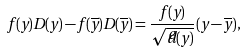<formula> <loc_0><loc_0><loc_500><loc_500>f ( y ) D ( y ) - f ( \overline { y } ) D ( \overline { y } ) = \frac { f ( y ) } { \sqrt { \widetilde { d } ( y ) } } ( y - \overline { y } ) ,</formula> 